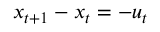Convert formula to latex. <formula><loc_0><loc_0><loc_500><loc_500>x _ { t + 1 } - x _ { t } = - u _ { t }</formula> 